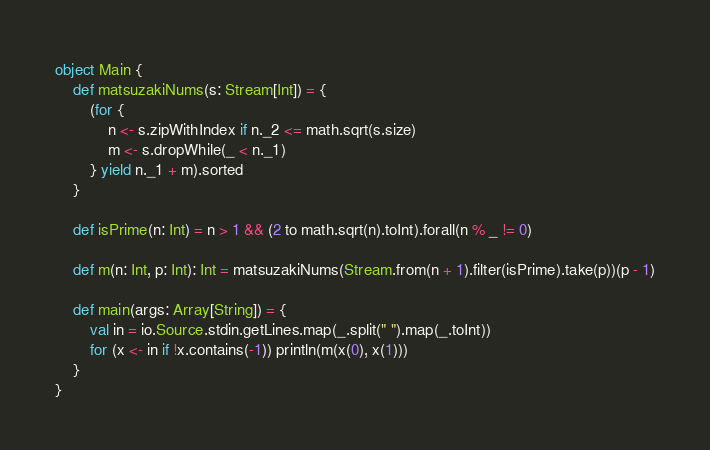<code> <loc_0><loc_0><loc_500><loc_500><_Scala_>object Main {
    def matsuzakiNums(s: Stream[Int]) = {
        (for {
            n <- s.zipWithIndex if n._2 <= math.sqrt(s.size)
            m <- s.dropWhile(_ < n._1)
        } yield n._1 + m).sorted
    }
            
    def isPrime(n: Int) = n > 1 && (2 to math.sqrt(n).toInt).forall(n % _ != 0)

    def m(n: Int, p: Int): Int = matsuzakiNums(Stream.from(n + 1).filter(isPrime).take(p))(p - 1)

    def main(args: Array[String]) = {
        val in = io.Source.stdin.getLines.map(_.split(" ").map(_.toInt))
        for (x <- in if !x.contains(-1)) println(m(x(0), x(1)))
    }
}</code> 